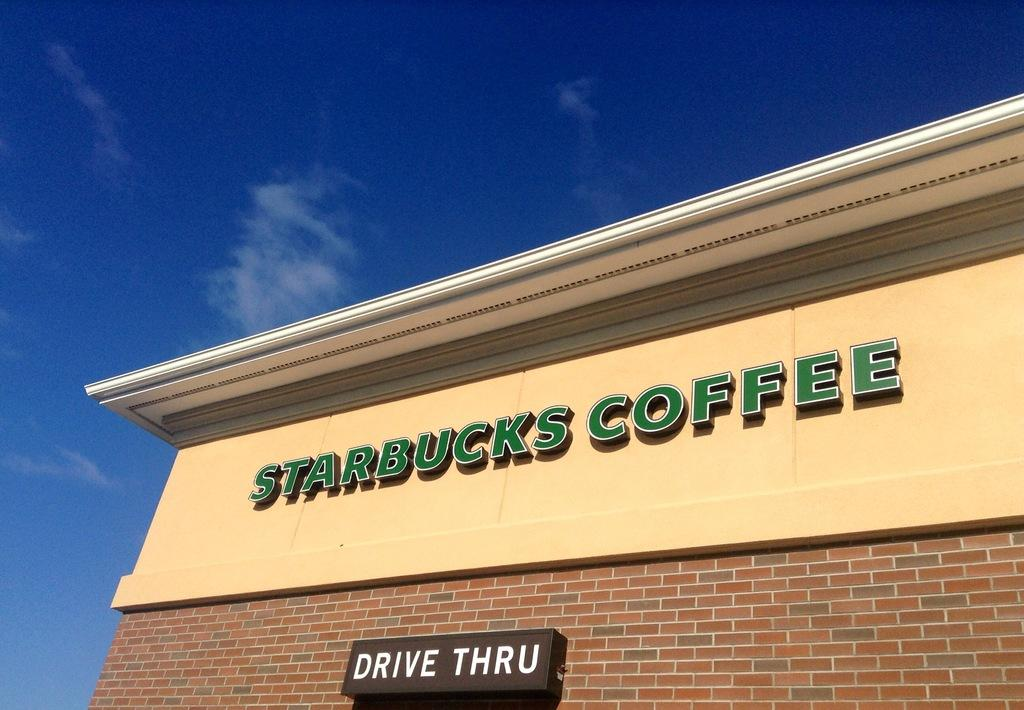What can be seen attached to the wall in the image? There are name boards attached to the wall in the image. What is visible in the background of the image? The sky is visible in the background of the image. What is the purpose of the dirt on the side of the wall in the image? There is no dirt present on the side of the wall in the image. 